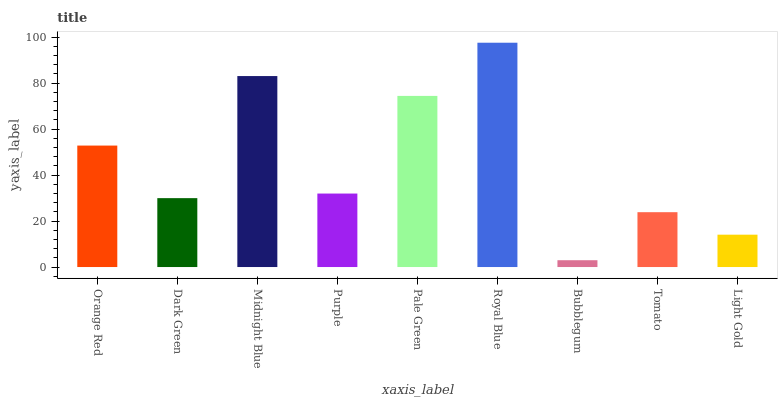Is Dark Green the minimum?
Answer yes or no. No. Is Dark Green the maximum?
Answer yes or no. No. Is Orange Red greater than Dark Green?
Answer yes or no. Yes. Is Dark Green less than Orange Red?
Answer yes or no. Yes. Is Dark Green greater than Orange Red?
Answer yes or no. No. Is Orange Red less than Dark Green?
Answer yes or no. No. Is Purple the high median?
Answer yes or no. Yes. Is Purple the low median?
Answer yes or no. Yes. Is Orange Red the high median?
Answer yes or no. No. Is Tomato the low median?
Answer yes or no. No. 